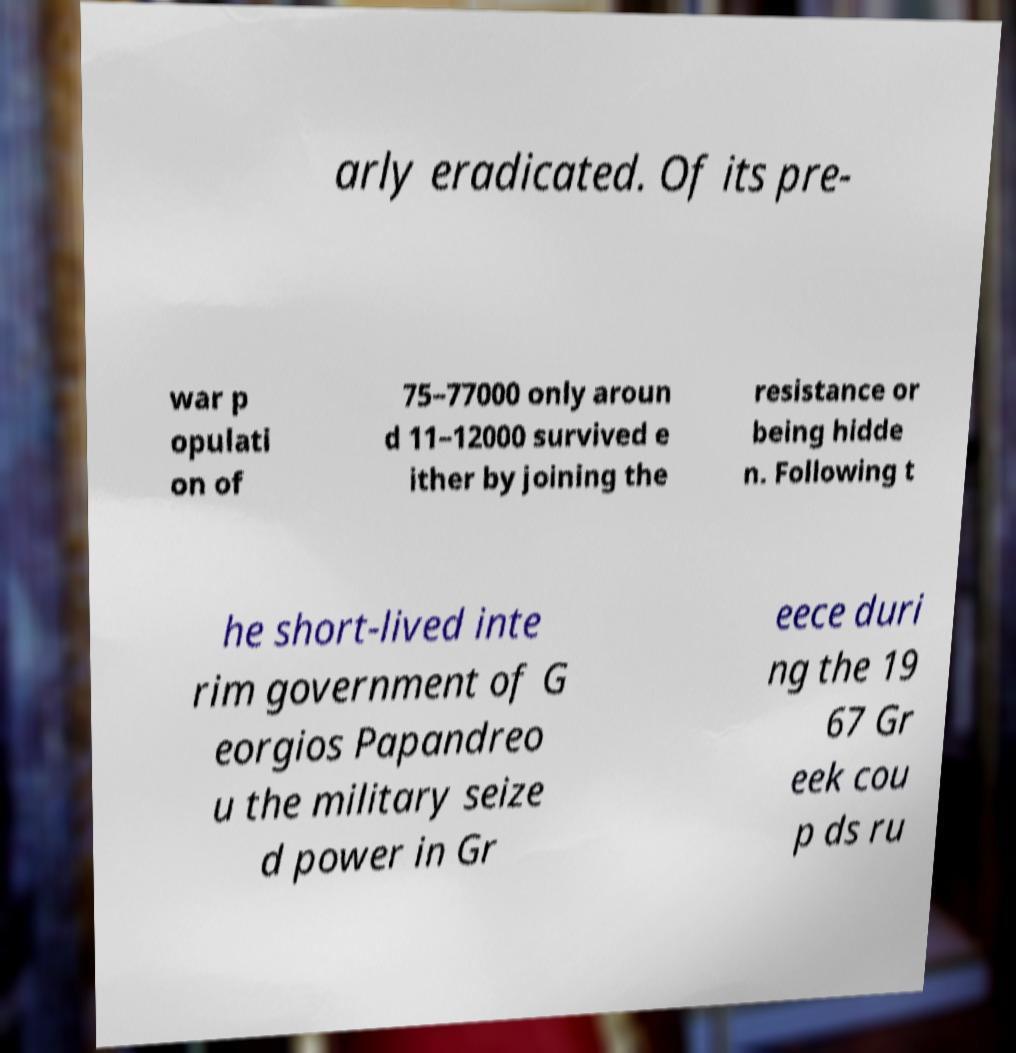Can you read and provide the text displayed in the image?This photo seems to have some interesting text. Can you extract and type it out for me? arly eradicated. Of its pre- war p opulati on of 75–77000 only aroun d 11–12000 survived e ither by joining the resistance or being hidde n. Following t he short-lived inte rim government of G eorgios Papandreo u the military seize d power in Gr eece duri ng the 19 67 Gr eek cou p ds ru 